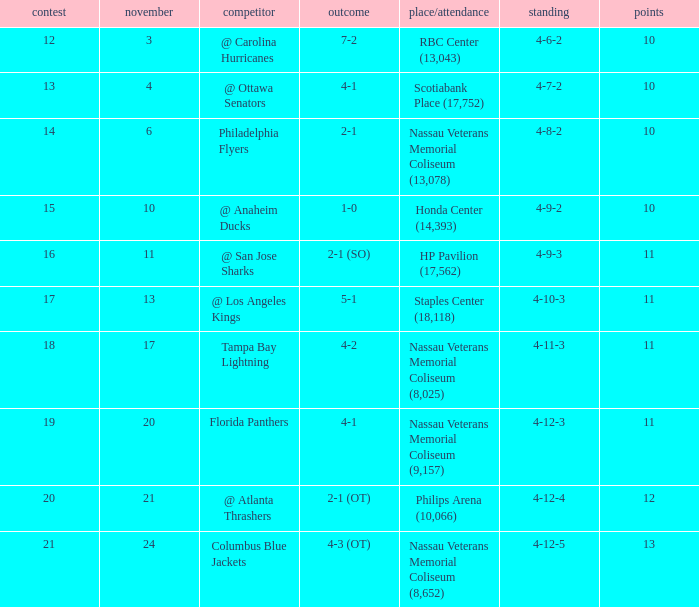For game 13, what are the individual records? 4-7-2. 